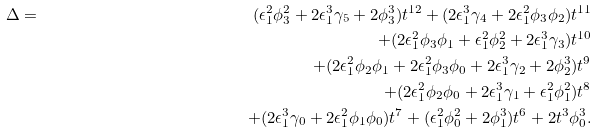Convert formula to latex. <formula><loc_0><loc_0><loc_500><loc_500>\Delta & = & ( { \epsilon } _ { 1 } ^ { 2 } \phi _ { 3 } ^ { 2 } + 2 { \epsilon } _ { 1 } ^ { 3 } \gamma _ { 5 } + 2 \phi _ { 3 } ^ { 3 } ) t ^ { 1 2 } + ( 2 { \epsilon } _ { 1 } ^ { 3 } \gamma _ { 4 } + 2 { \epsilon } _ { 1 } ^ { 2 } \phi _ { 3 } \phi _ { 2 } ) t ^ { 1 1 } \\ & & + ( 2 { \epsilon } _ { 1 } ^ { 2 } \phi _ { 3 } \phi _ { 1 } + { \epsilon } _ { 1 } ^ { 2 } \phi _ { 2 } ^ { 2 } + 2 { \epsilon } _ { 1 } ^ { 3 } \gamma _ { 3 } ) t ^ { 1 0 } \\ & & + ( 2 { \epsilon } _ { 1 } ^ { 2 } \phi _ { 2 } \phi _ { 1 } + 2 { \epsilon } _ { 1 } ^ { 2 } \phi _ { 3 } \phi _ { 0 } + 2 { \epsilon } _ { 1 } ^ { 3 } \gamma _ { 2 } + 2 \phi _ { 2 } ^ { 3 } ) t ^ { 9 } \\ & & + ( 2 { \epsilon } _ { 1 } ^ { 2 } \phi _ { 2 } \phi _ { 0 } + 2 { \epsilon } _ { 1 } ^ { 3 } \gamma _ { 1 } + { \epsilon } _ { 1 } ^ { 2 } \phi _ { 1 } ^ { 2 } ) t ^ { 8 } \\ & & + ( 2 { \epsilon } _ { 1 } ^ { 3 } \gamma _ { 0 } + 2 { \epsilon } _ { 1 } ^ { 2 } \phi _ { 1 } \phi _ { 0 } ) t ^ { 7 } + ( { \epsilon } _ { 1 } ^ { 2 } \phi _ { 0 } ^ { 2 } + 2 \phi _ { 1 } ^ { 3 } ) t ^ { 6 } + 2 t ^ { 3 } \phi _ { 0 } ^ { 3 } .</formula> 